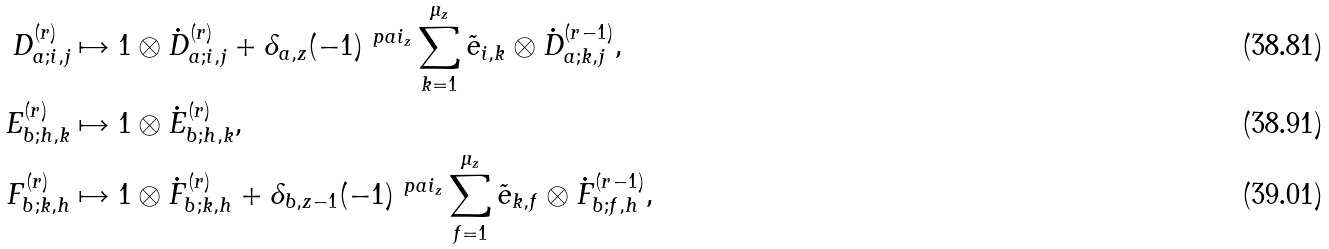Convert formula to latex. <formula><loc_0><loc_0><loc_500><loc_500>D _ { a ; i , j } ^ { ( r ) } & \mapsto 1 \otimes \dot { D } _ { a ; i , j } ^ { ( r ) } + \delta _ { a , z } ( - 1 ) ^ { \ p a { i } _ { z } } \sum _ { k = 1 } ^ { \mu _ { z } } \tilde { e } _ { i , k } \otimes \dot { D } _ { a ; k , j } ^ { ( r - 1 ) } , \\ E _ { b ; h , k } ^ { ( r ) } & \mapsto 1 \otimes \dot { E } _ { b ; h , k } ^ { ( r ) } , \\ F _ { b ; k , h } ^ { ( r ) } & \mapsto 1 \otimes \dot { F } _ { b ; k , h } ^ { ( r ) } + \delta _ { b , z - 1 } ( - 1 ) ^ { \ p a { i } _ { z } } \sum _ { f = 1 } ^ { \mu _ { z } } \tilde { e } _ { k , f } \otimes \dot { F } _ { b ; f , h } ^ { ( r - 1 ) } ,</formula> 